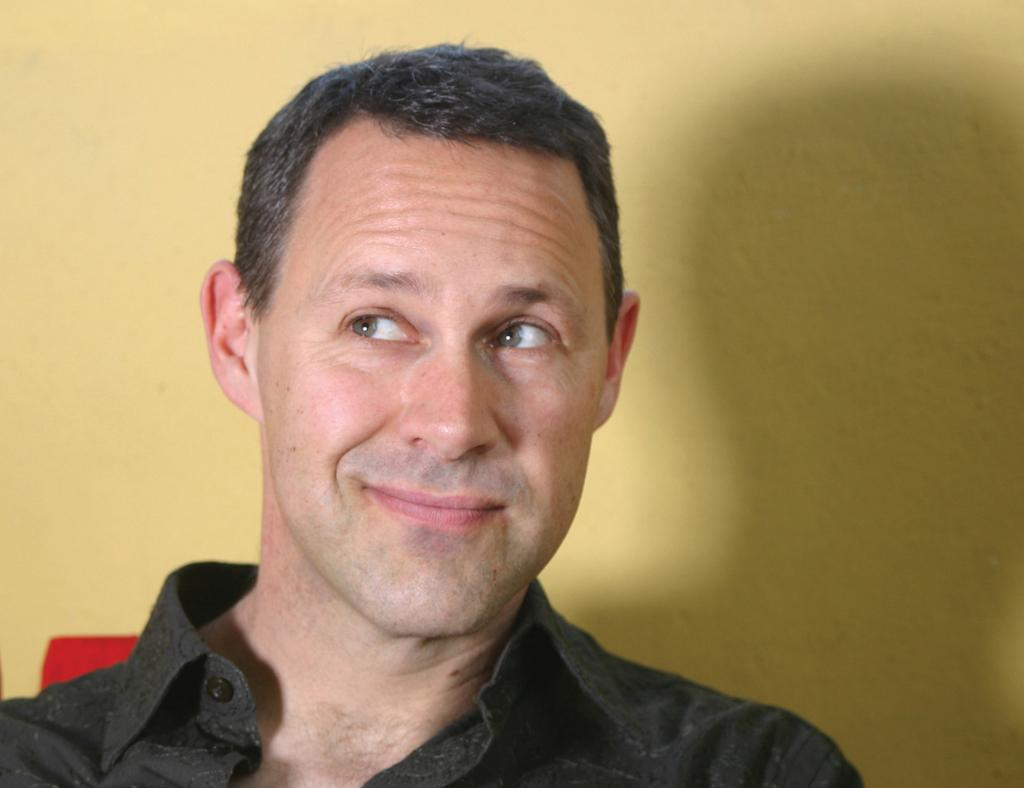Who is present in the image? There is a man in the image. What color is the wall visible in the image? The wall in the image is yellow. Can you describe the setting of the image? The image may have been taken in a room, as suggested by the presence of a wall. What nation does the man in the image represent? There is no information in the image to determine which nation the man represents. 